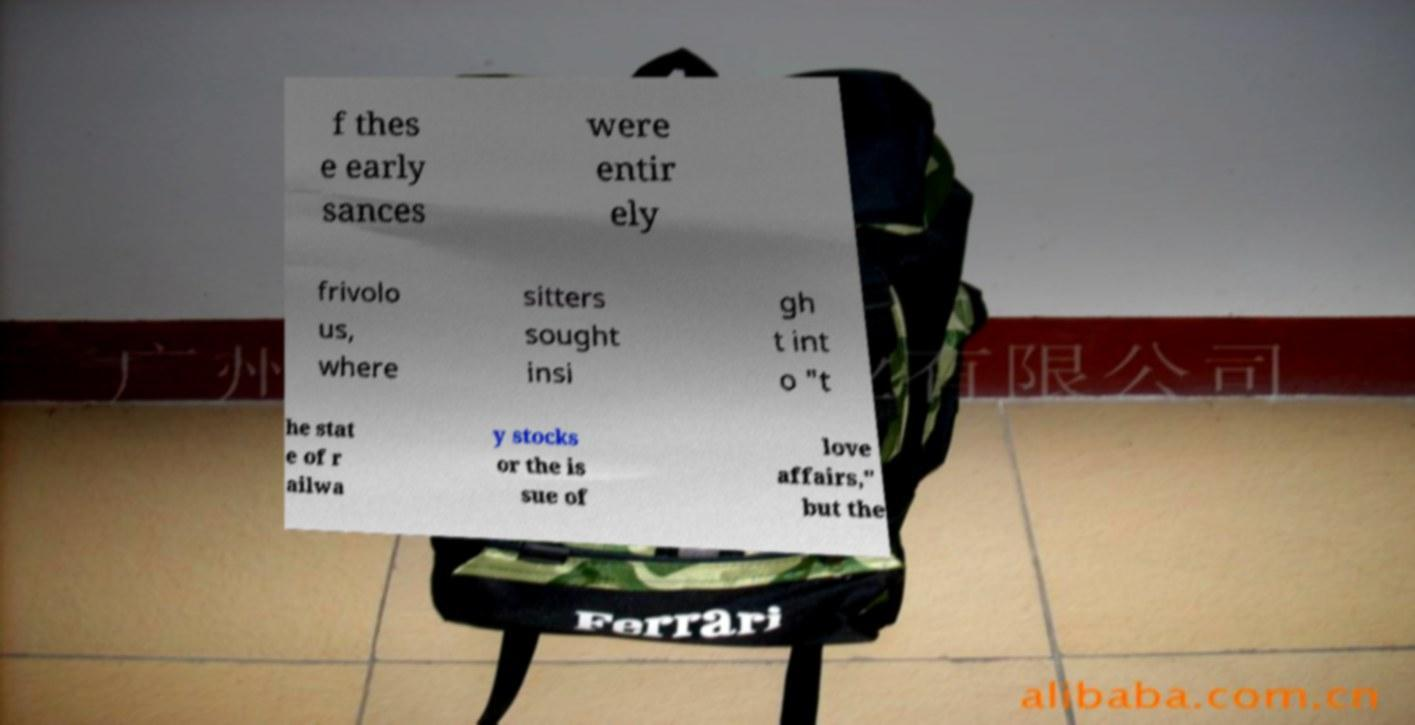There's text embedded in this image that I need extracted. Can you transcribe it verbatim? f thes e early sances were entir ely frivolo us, where sitters sought insi gh t int o "t he stat e of r ailwa y stocks or the is sue of love affairs," but the 